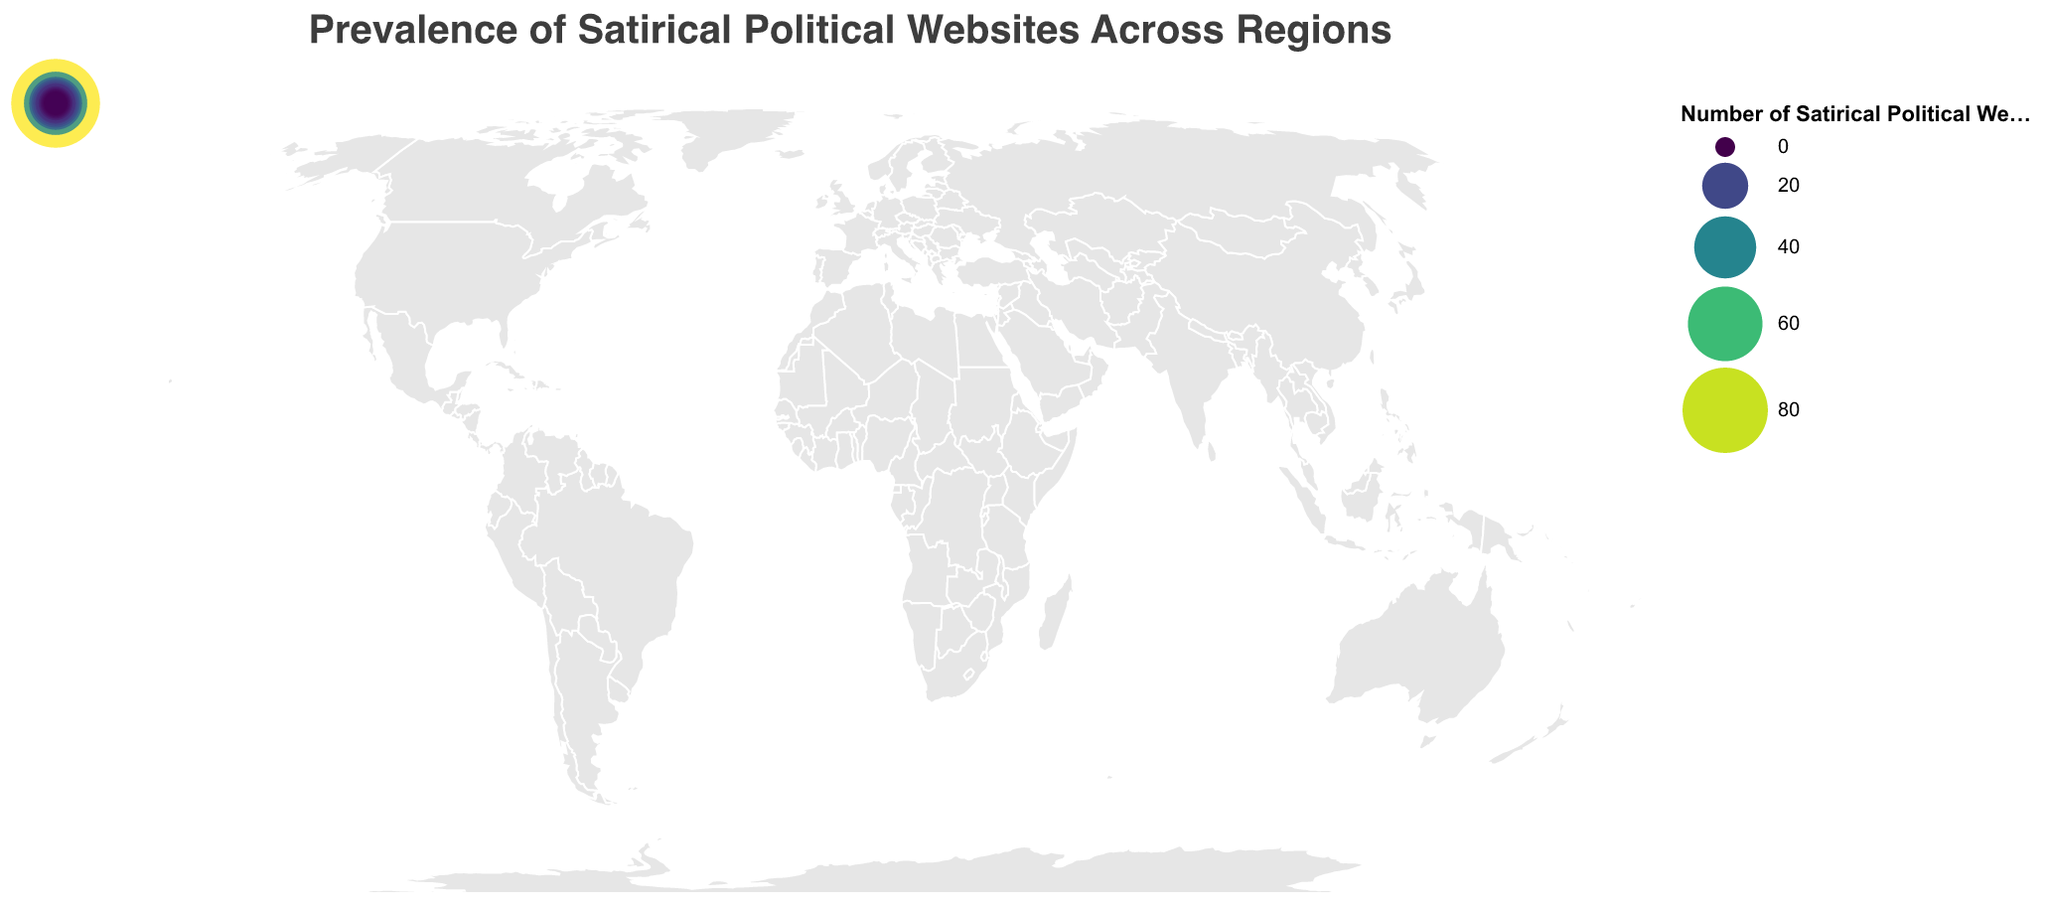What's the title of the figure? The title is located at the top of the figure. It reads: "Prevalence of Satirical Political Websites Across Regions".
Answer: Prevalence of Satirical Political Websites Across Regions Which region has the highest number of satirical political websites? Look for the region with the largest circle. The size of the circle represents the number of satirical political websites. The United States has the largest circle.
Answer: United States How many satirical political websites are there in Germany and France combined? Find the number of satirical political websites for Germany and France. Germany has 19 and France has 15. Adding these together: 19 + 15 = 34.
Answer: 34 Which region has fewer satirical political websites, Brazil or Mexico? Compare the number of satirical political websites in Brazil (7) and Mexico (4). Brazil has more, so Mexico has fewer.
Answer: Mexico What is the difference in the number of satirical political websites between the United Kingdom and Canada? The United Kingdom has 42 and Canada has 28. Subtract the smaller number from the larger: 42 - 28 = 14.
Answer: 14 Identify the region in Asia with the highest number of satirical political websites. Refer to the Asian regions listed: India, Japan, and Russia. India has 13, which is the highest among them.
Answer: India How many regions have more than 10 satirical political websites? Scan the list for regions with numbers greater than 10: United States (87), United Kingdom (42), Canada (28), Australia (23), Germany (19), France (15), and India (13). There are 7 regions.
Answer: 7 Which region has the smallest number of satirical political websites, and how many does it have? Look for the region with the smallest circle. Sweden has the smallest circle with 2 satirical political websites.
Answer: Sweden, 2 What is the total number of satirical political websites represented in the figure? Sum the numbers of satirical political websites in all regions:
87 (US) + 42 (UK) + 28 (Canada) + 23 (Australia) + 19 (Germany) + 15 (France) + 13 (India) + 9 (South Africa) + 7 (Brazil) + 6 (Russia) + 5 (Japan) + 4 (Mexico) + 4 (Spain) + 3 (Italy) + 2 (Sweden) = 267.
Answer: 267 What is the average number of satirical political websites per region? Total number of websites is 267, and there are 15 regions. Divide the total by the number of regions: 267 / 15 ≈ 17.8.
Answer: 17.8 